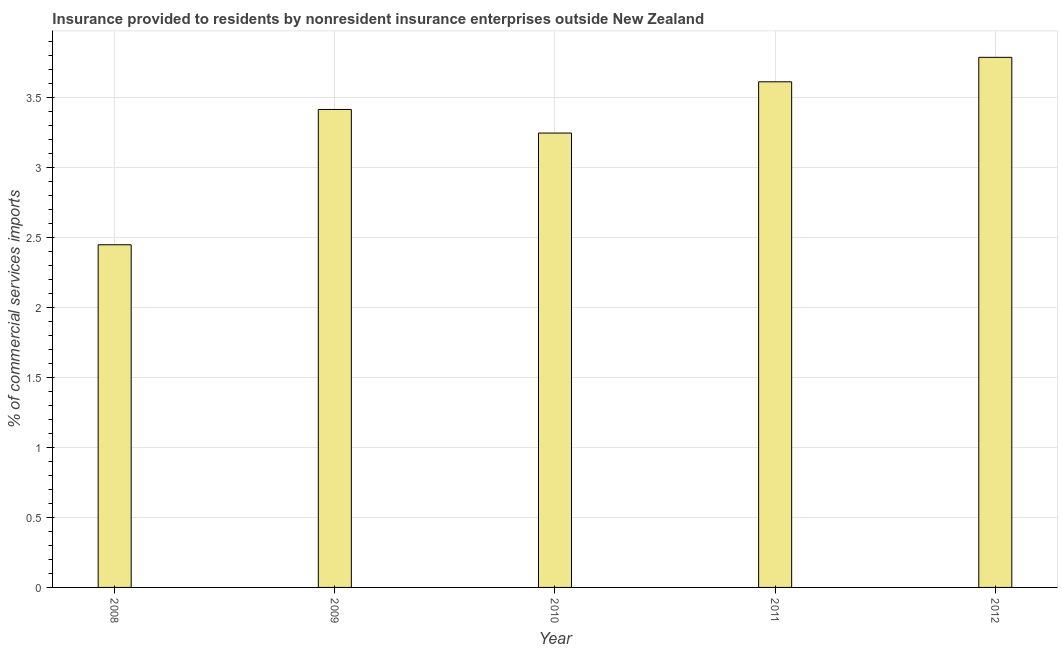Does the graph contain grids?
Your answer should be compact. Yes. What is the title of the graph?
Provide a succinct answer. Insurance provided to residents by nonresident insurance enterprises outside New Zealand. What is the label or title of the Y-axis?
Your response must be concise. % of commercial services imports. What is the insurance provided by non-residents in 2011?
Ensure brevity in your answer.  3.61. Across all years, what is the maximum insurance provided by non-residents?
Your answer should be very brief. 3.79. Across all years, what is the minimum insurance provided by non-residents?
Keep it short and to the point. 2.45. What is the sum of the insurance provided by non-residents?
Provide a succinct answer. 16.51. What is the difference between the insurance provided by non-residents in 2008 and 2010?
Your answer should be very brief. -0.8. What is the average insurance provided by non-residents per year?
Ensure brevity in your answer.  3.3. What is the median insurance provided by non-residents?
Make the answer very short. 3.42. What is the ratio of the insurance provided by non-residents in 2010 to that in 2011?
Your response must be concise. 0.9. What is the difference between the highest and the second highest insurance provided by non-residents?
Make the answer very short. 0.17. Is the sum of the insurance provided by non-residents in 2009 and 2011 greater than the maximum insurance provided by non-residents across all years?
Provide a short and direct response. Yes. What is the difference between the highest and the lowest insurance provided by non-residents?
Your response must be concise. 1.34. Are all the bars in the graph horizontal?
Keep it short and to the point. No. How many years are there in the graph?
Your answer should be very brief. 5. What is the difference between two consecutive major ticks on the Y-axis?
Give a very brief answer. 0.5. What is the % of commercial services imports in 2008?
Make the answer very short. 2.45. What is the % of commercial services imports of 2009?
Provide a succinct answer. 3.42. What is the % of commercial services imports in 2010?
Your response must be concise. 3.25. What is the % of commercial services imports in 2011?
Your answer should be compact. 3.61. What is the % of commercial services imports in 2012?
Provide a short and direct response. 3.79. What is the difference between the % of commercial services imports in 2008 and 2009?
Give a very brief answer. -0.97. What is the difference between the % of commercial services imports in 2008 and 2010?
Ensure brevity in your answer.  -0.8. What is the difference between the % of commercial services imports in 2008 and 2011?
Provide a short and direct response. -1.16. What is the difference between the % of commercial services imports in 2008 and 2012?
Your answer should be very brief. -1.34. What is the difference between the % of commercial services imports in 2009 and 2010?
Keep it short and to the point. 0.17. What is the difference between the % of commercial services imports in 2009 and 2011?
Your answer should be compact. -0.2. What is the difference between the % of commercial services imports in 2009 and 2012?
Ensure brevity in your answer.  -0.37. What is the difference between the % of commercial services imports in 2010 and 2011?
Your answer should be compact. -0.37. What is the difference between the % of commercial services imports in 2010 and 2012?
Offer a terse response. -0.54. What is the difference between the % of commercial services imports in 2011 and 2012?
Provide a succinct answer. -0.17. What is the ratio of the % of commercial services imports in 2008 to that in 2009?
Ensure brevity in your answer.  0.72. What is the ratio of the % of commercial services imports in 2008 to that in 2010?
Your answer should be compact. 0.75. What is the ratio of the % of commercial services imports in 2008 to that in 2011?
Ensure brevity in your answer.  0.68. What is the ratio of the % of commercial services imports in 2008 to that in 2012?
Provide a short and direct response. 0.65. What is the ratio of the % of commercial services imports in 2009 to that in 2010?
Your answer should be compact. 1.05. What is the ratio of the % of commercial services imports in 2009 to that in 2011?
Keep it short and to the point. 0.94. What is the ratio of the % of commercial services imports in 2009 to that in 2012?
Your answer should be compact. 0.9. What is the ratio of the % of commercial services imports in 2010 to that in 2011?
Give a very brief answer. 0.9. What is the ratio of the % of commercial services imports in 2010 to that in 2012?
Provide a short and direct response. 0.86. What is the ratio of the % of commercial services imports in 2011 to that in 2012?
Provide a short and direct response. 0.95. 